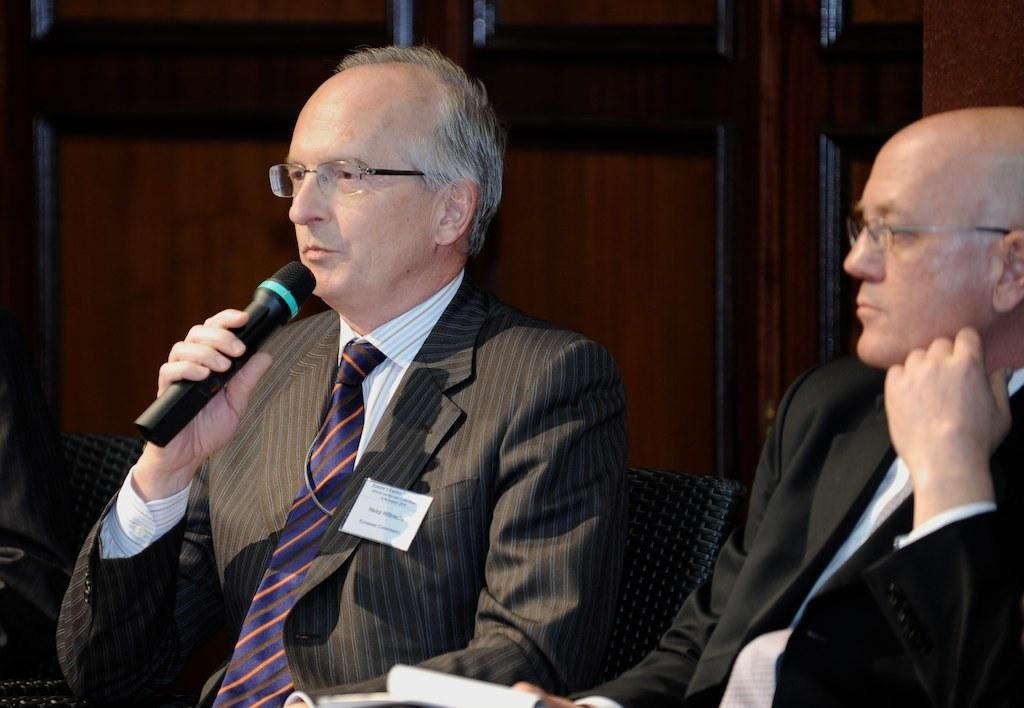How many people are in the image? There are two men in the image. What are the men doing in the image? The men are sitting in chairs. What can be observed about the men's appearance? Both men are wearing spectacles. What is one of the men holding in his hand? One of the men is holding a mic in his hand. What can be seen in the background of the image? There is a wall in the background of the image. Can you see a kitty playing with a tent in the image? There is no kitty or tent present in the image. 